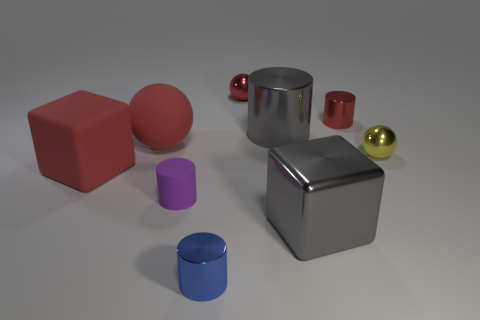There is a purple matte cylinder; are there any cylinders right of it?
Offer a very short reply. Yes. What number of objects are either small objects that are in front of the red matte cube or blue rubber balls?
Provide a short and direct response. 2. What number of red objects are tiny cylinders or big cylinders?
Your answer should be compact. 1. How many other objects are the same color as the large sphere?
Keep it short and to the point. 3. Are there fewer gray metal blocks in front of the yellow thing than yellow things?
Your response must be concise. No. The tiny sphere that is to the right of the gray object in front of the large block left of the tiny blue object is what color?
Provide a succinct answer. Yellow. Are there any other things that are the same material as the small blue cylinder?
Your answer should be very brief. Yes. There is a matte thing that is the same shape as the yellow metallic object; what is its size?
Keep it short and to the point. Large. Are there fewer big gray shiny blocks behind the large gray cube than objects in front of the small red metal cylinder?
Ensure brevity in your answer.  Yes. What shape is the red thing that is both in front of the red metal cylinder and right of the red matte block?
Offer a terse response. Sphere. 